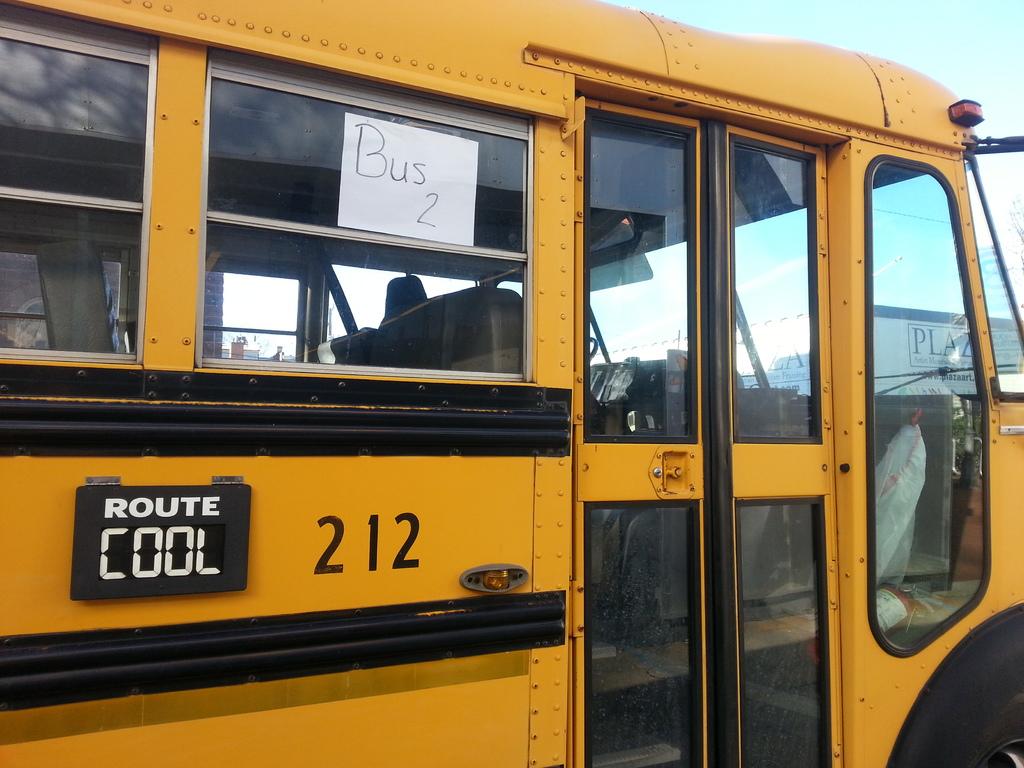Which route is this?
Your response must be concise. Cool. 